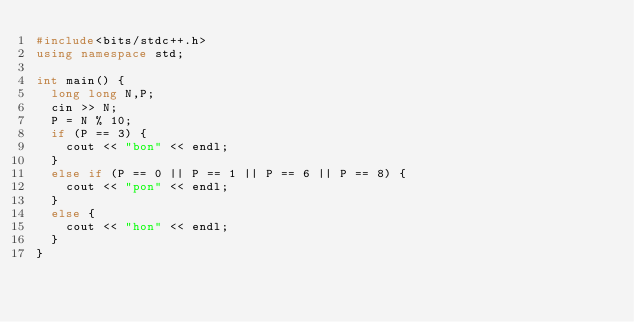<code> <loc_0><loc_0><loc_500><loc_500><_C++_>#include<bits/stdc++.h>
using namespace std;

int main() {
  long long N,P;
  cin >> N;
  P = N % 10;
  if (P == 3) {
    cout << "bon" << endl;
  }
  else if (P == 0 || P == 1 || P == 6 || P == 8) {
    cout << "pon" << endl;
  }
  else {
    cout << "hon" << endl;
  }
}
</code> 